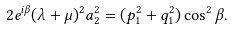<formula> <loc_0><loc_0><loc_500><loc_500>2 e ^ { i \beta } ( \lambda + \mu ) ^ { 2 } a _ { 2 } ^ { 2 } = ( p _ { 1 } ^ { 2 } + q _ { 1 } ^ { 2 } ) \cos ^ { 2 } \beta .</formula> 